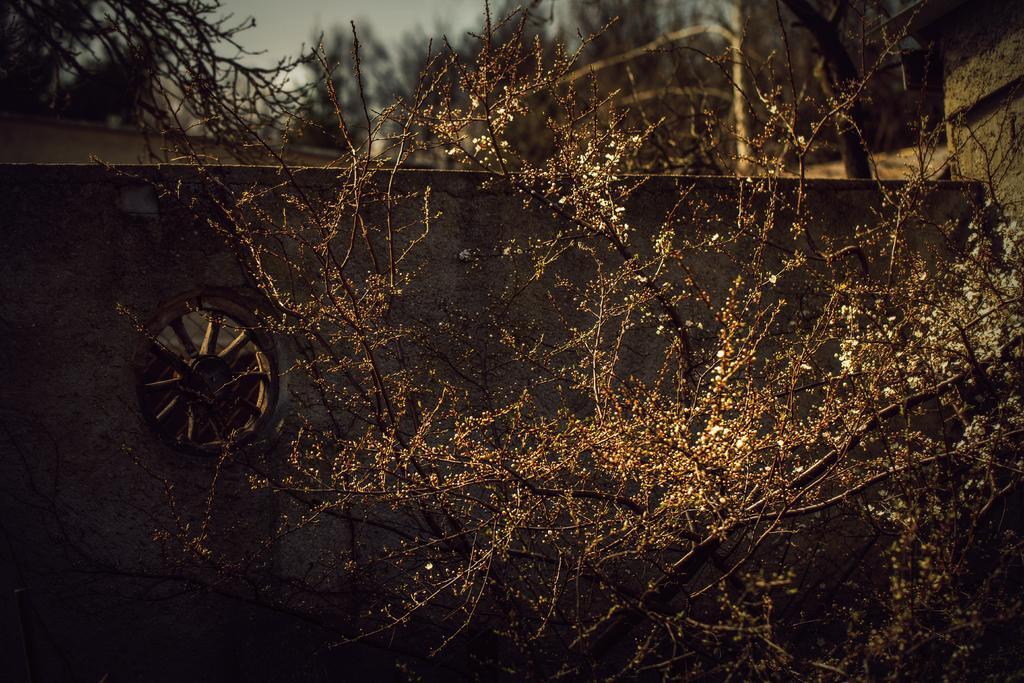In one or two sentences, can you explain what this image depicts? In this picture, we can see some trees. On the left side, we can also see a tyre. In the background there are some trees. On the top, we can see a sky. 